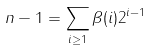Convert formula to latex. <formula><loc_0><loc_0><loc_500><loc_500>n - 1 = \sum _ { i \geq 1 } \beta ( i ) 2 ^ { i - 1 }</formula> 